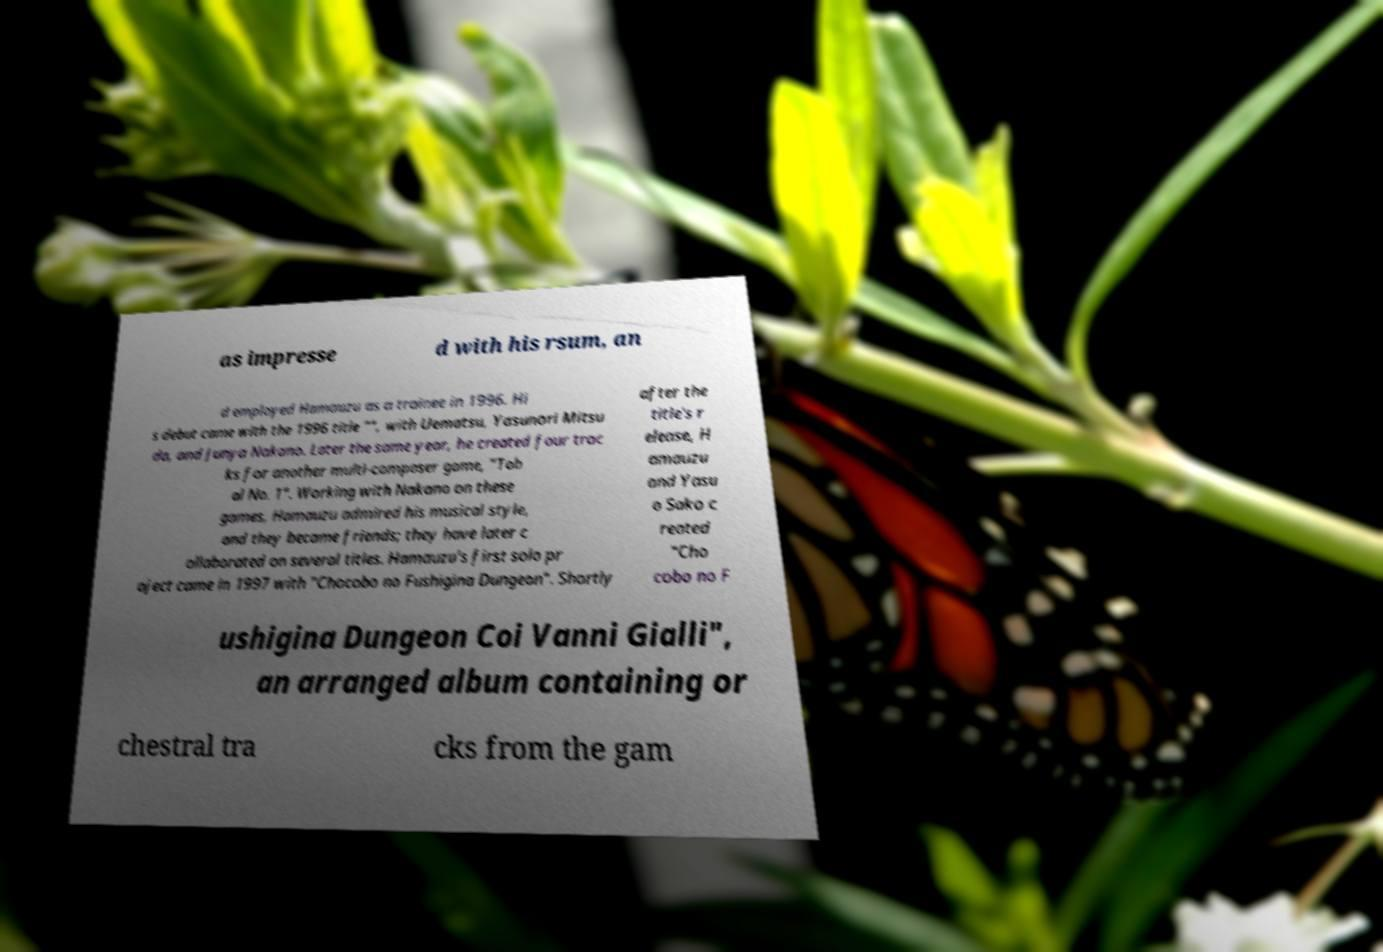There's text embedded in this image that I need extracted. Can you transcribe it verbatim? as impresse d with his rsum, an d employed Hamauzu as a trainee in 1996. Hi s debut came with the 1996 title "", with Uematsu, Yasunori Mitsu da, and Junya Nakano. Later the same year, he created four trac ks for another multi-composer game, "Tob al No. 1". Working with Nakano on these games, Hamauzu admired his musical style, and they became friends; they have later c ollaborated on several titles. Hamauzu's first solo pr oject came in 1997 with "Chocobo no Fushigina Dungeon". Shortly after the title's r elease, H amauzu and Yasu o Sako c reated "Cho cobo no F ushigina Dungeon Coi Vanni Gialli", an arranged album containing or chestral tra cks from the gam 